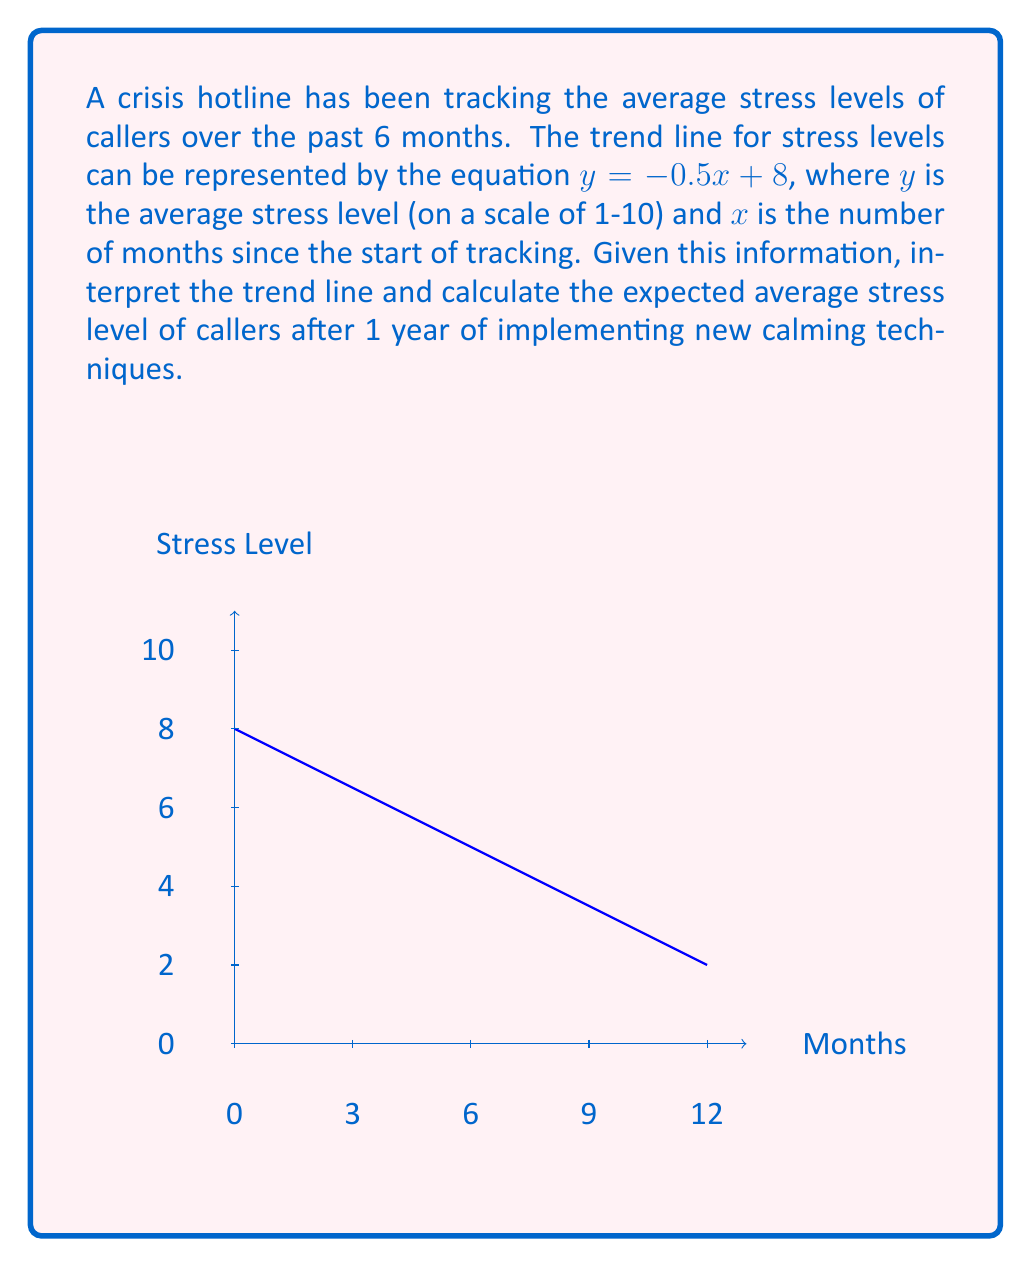Solve this math problem. To interpret the trend line and calculate the expected average stress level after 1 year:

1) Interpret the trend line:
   - The equation $y = -0.5x + 8$ shows a negative slope (-0.5).
   - This indicates that stress levels are decreasing over time.
   - The y-intercept (8) represents the initial average stress level.

2) Calculate the stress level after 1 year:
   - 1 year = 12 months
   - Substitute $x = 12$ into the equation:
     $y = -0.5(12) + 8$
   - Simplify:
     $y = -6 + 8 = 2$

3) Interpret the result:
   - The expected average stress level after 1 year is 2 on a scale of 1-10.
   - This represents a significant decrease from the initial level of 8.

4) Additional interpretation for the crisis hotline context:
   - The decreasing trend suggests that the new calming techniques implemented by the retired officer and other operators are effective.
   - The substantial reduction in stress levels indicates improved caller outcomes over time.
Answer: 2 